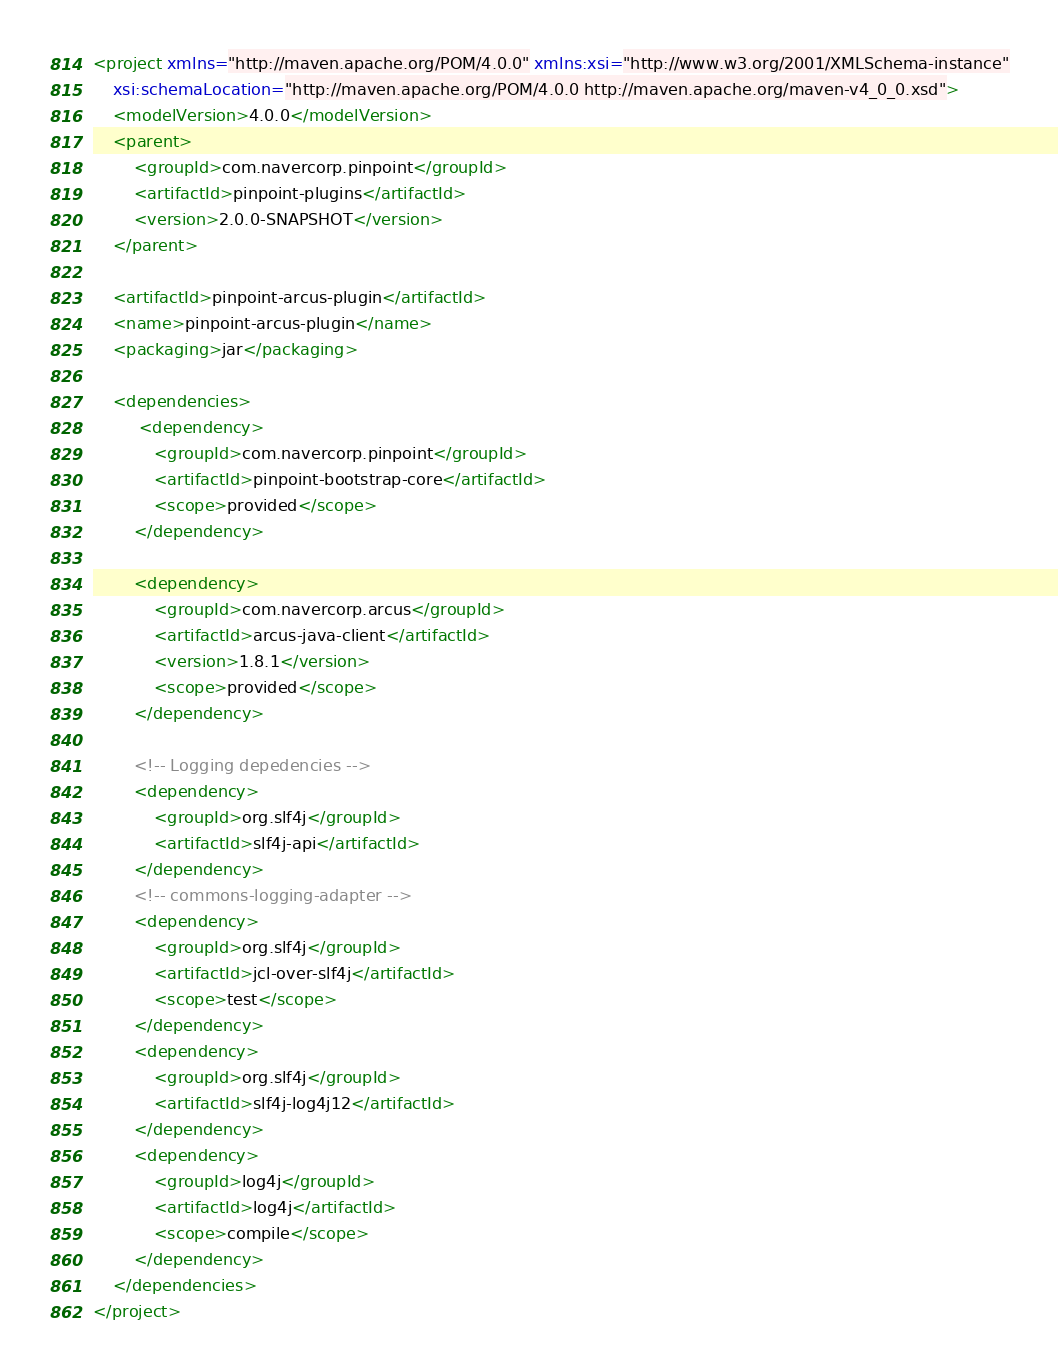Convert code to text. <code><loc_0><loc_0><loc_500><loc_500><_XML_><project xmlns="http://maven.apache.org/POM/4.0.0" xmlns:xsi="http://www.w3.org/2001/XMLSchema-instance"
    xsi:schemaLocation="http://maven.apache.org/POM/4.0.0 http://maven.apache.org/maven-v4_0_0.xsd">
    <modelVersion>4.0.0</modelVersion>
    <parent>
        <groupId>com.navercorp.pinpoint</groupId>
        <artifactId>pinpoint-plugins</artifactId>
        <version>2.0.0-SNAPSHOT</version>
    </parent>

    <artifactId>pinpoint-arcus-plugin</artifactId>
    <name>pinpoint-arcus-plugin</name>
    <packaging>jar</packaging>

    <dependencies>
         <dependency>
            <groupId>com.navercorp.pinpoint</groupId>
            <artifactId>pinpoint-bootstrap-core</artifactId>
            <scope>provided</scope>
        </dependency>
    
        <dependency>
            <groupId>com.navercorp.arcus</groupId>
            <artifactId>arcus-java-client</artifactId>
            <version>1.8.1</version>
            <scope>provided</scope>
        </dependency>

        <!-- Logging depedencies -->
        <dependency>
            <groupId>org.slf4j</groupId>
            <artifactId>slf4j-api</artifactId>
        </dependency>
        <!-- commons-logging-adapter -->
        <dependency>
            <groupId>org.slf4j</groupId>
            <artifactId>jcl-over-slf4j</artifactId>
            <scope>test</scope>
        </dependency>
        <dependency>
            <groupId>org.slf4j</groupId>
            <artifactId>slf4j-log4j12</artifactId>
        </dependency>
        <dependency>
            <groupId>log4j</groupId>
            <artifactId>log4j</artifactId>
            <scope>compile</scope>
        </dependency>
    </dependencies>
</project>
</code> 